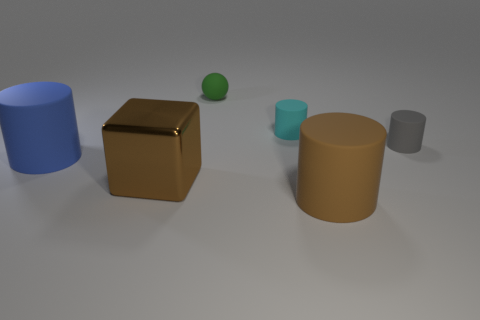Subtract all cyan matte cylinders. How many cylinders are left? 3 Add 4 small yellow metal balls. How many objects exist? 10 Subtract 2 cylinders. How many cylinders are left? 2 Subtract all brown cylinders. How many cylinders are left? 3 Subtract all spheres. How many objects are left? 5 Add 6 large rubber objects. How many large rubber objects are left? 8 Add 2 yellow cylinders. How many yellow cylinders exist? 2 Subtract 0 purple balls. How many objects are left? 6 Subtract all yellow cylinders. Subtract all green balls. How many cylinders are left? 4 Subtract all red shiny cubes. Subtract all small green spheres. How many objects are left? 5 